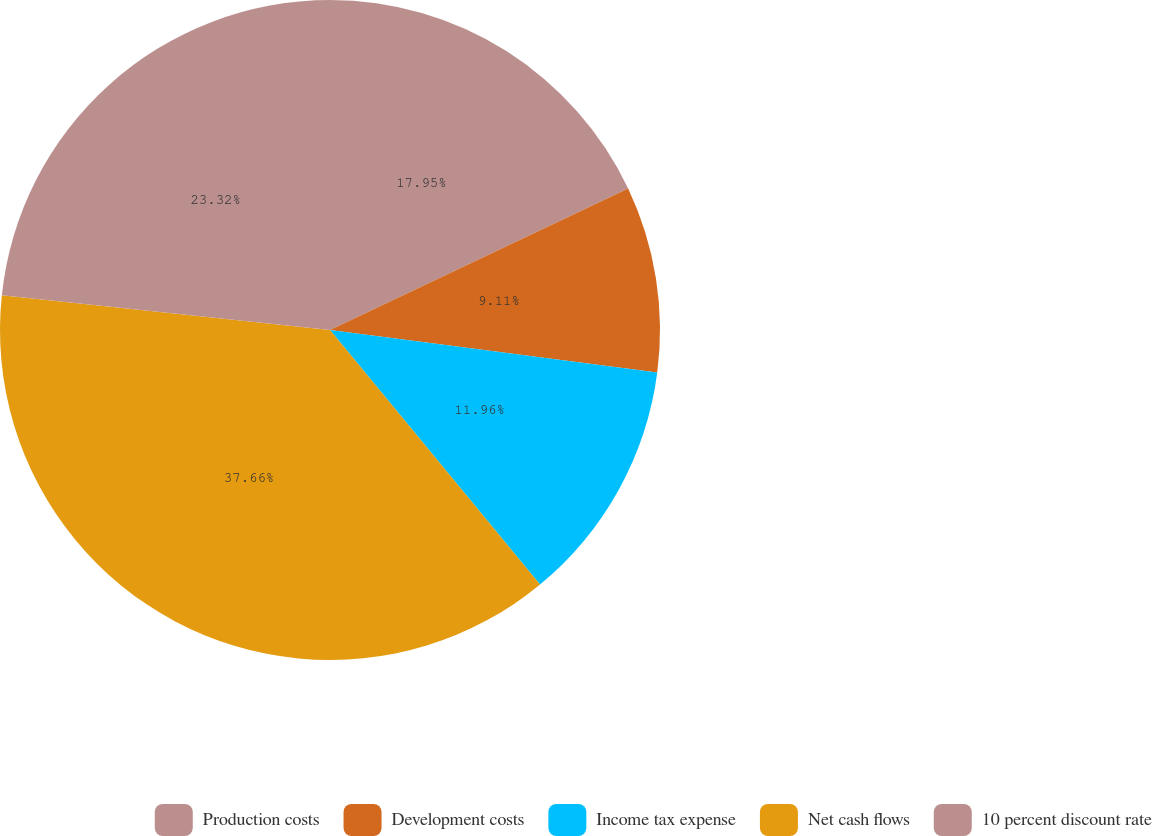Convert chart. <chart><loc_0><loc_0><loc_500><loc_500><pie_chart><fcel>Production costs<fcel>Development costs<fcel>Income tax expense<fcel>Net cash flows<fcel>10 percent discount rate<nl><fcel>17.95%<fcel>9.11%<fcel>11.96%<fcel>37.66%<fcel>23.32%<nl></chart> 